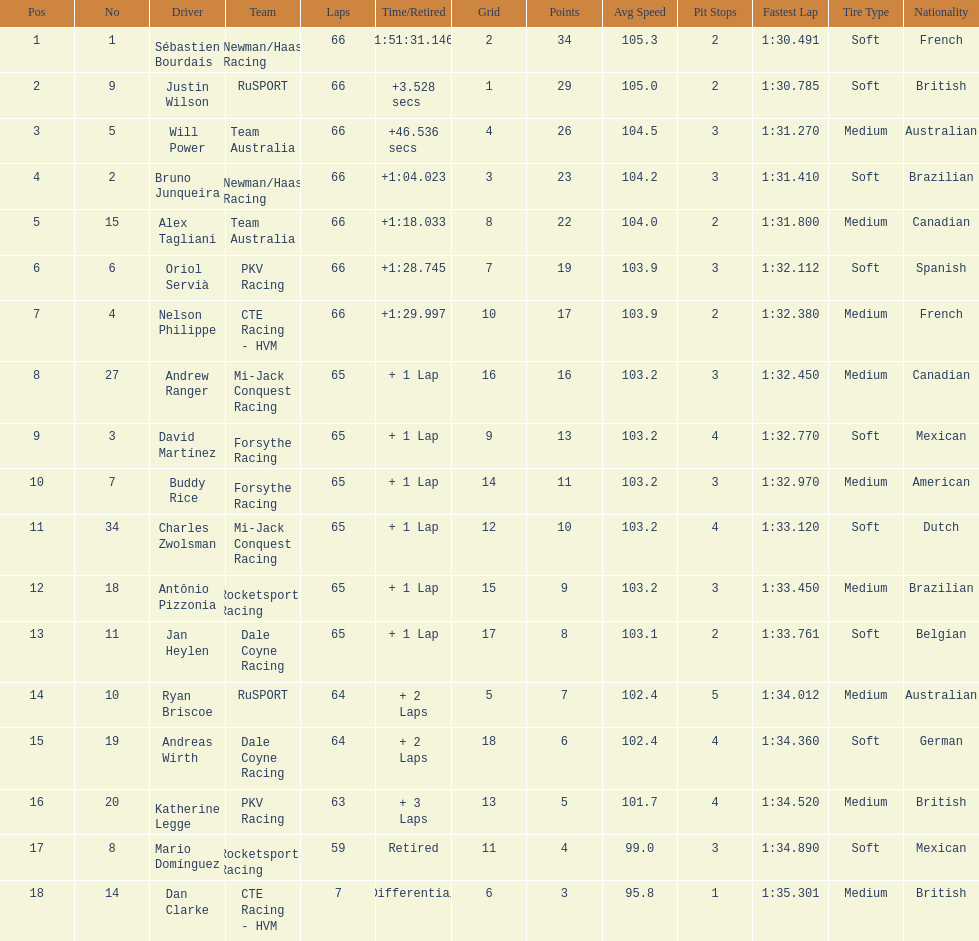Rice finished 10th. who finished next? Charles Zwolsman. 